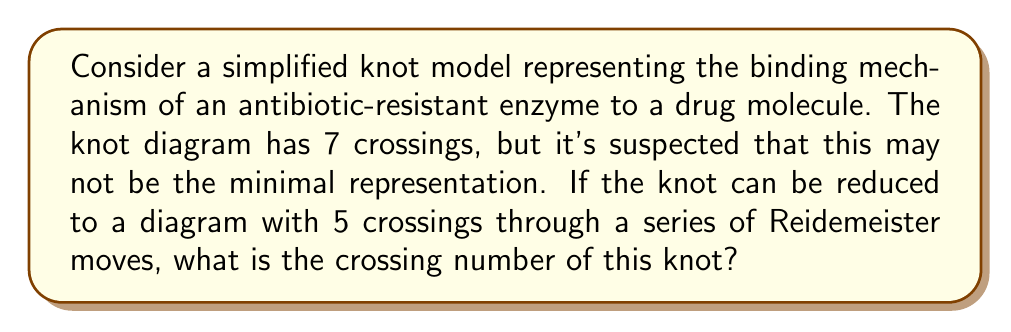Teach me how to tackle this problem. To solve this problem, we need to understand the concept of crossing number in knot theory and how it relates to knot diagrams:

1. The crossing number of a knot is defined as the minimum number of crossings in any diagram of the knot.

2. A given knot diagram may not always represent the minimal crossing configuration.

3. Reidemeister moves are operations that can be performed on a knot diagram without changing the underlying knot type. These moves can sometimes reduce the number of crossings.

4. If a knot diagram with fewer crossings can be obtained through Reidemeister moves, it means the original diagram was not minimal.

5. In this case, we're given:
   - An initial diagram with 7 crossings
   - Information that the knot can be reduced to a diagram with 5 crossings

6. Since we can obtain a diagram with fewer crossings (5) than the original (7), we know that 7 is not the crossing number.

7. The question states that the knot can be reduced to a diagram with 5 crossings, but it doesn't specify if this is the absolute minimum.

8. However, in knot theory, if we can obtain a diagram with a certain number of crossings through valid moves, and no lower crossing number is specified, we assume this is the minimal representation.

Therefore, the crossing number of this knot is 5.

This simplified model could represent how the structure of an antibiotic-resistant enzyme interacts with a drug molecule, with the crossings symbolizing key interaction points that contribute to the resistance mechanism.
Answer: 5 